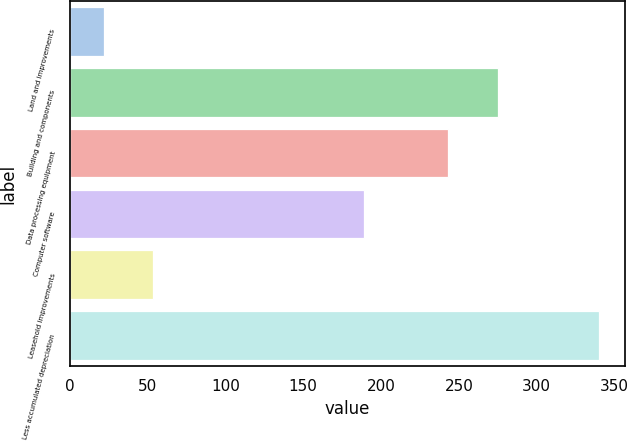Convert chart to OTSL. <chart><loc_0><loc_0><loc_500><loc_500><bar_chart><fcel>Land and improvements<fcel>Building and components<fcel>Data processing equipment<fcel>Computer software<fcel>Leasehold improvements<fcel>Less accumulated depreciation<nl><fcel>21.8<fcel>275.1<fcel>243.3<fcel>189.4<fcel>53.6<fcel>339.8<nl></chart> 